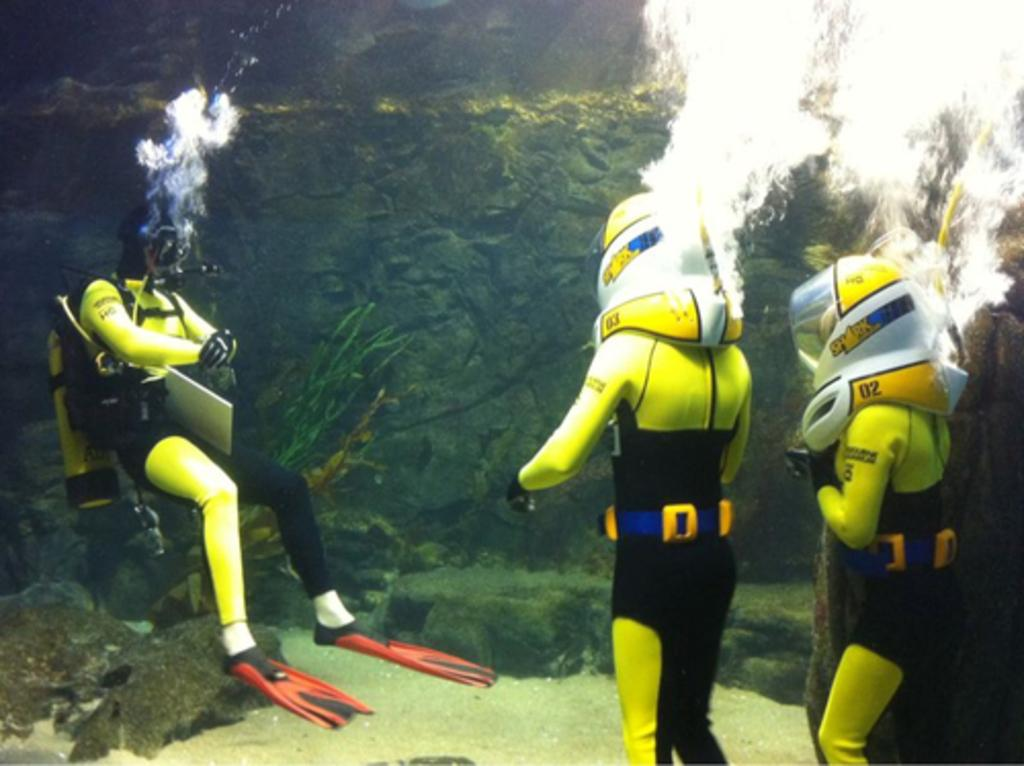<image>
Share a concise interpretation of the image provided. some deep sea divers, one of whom has the number 3 on their arm 